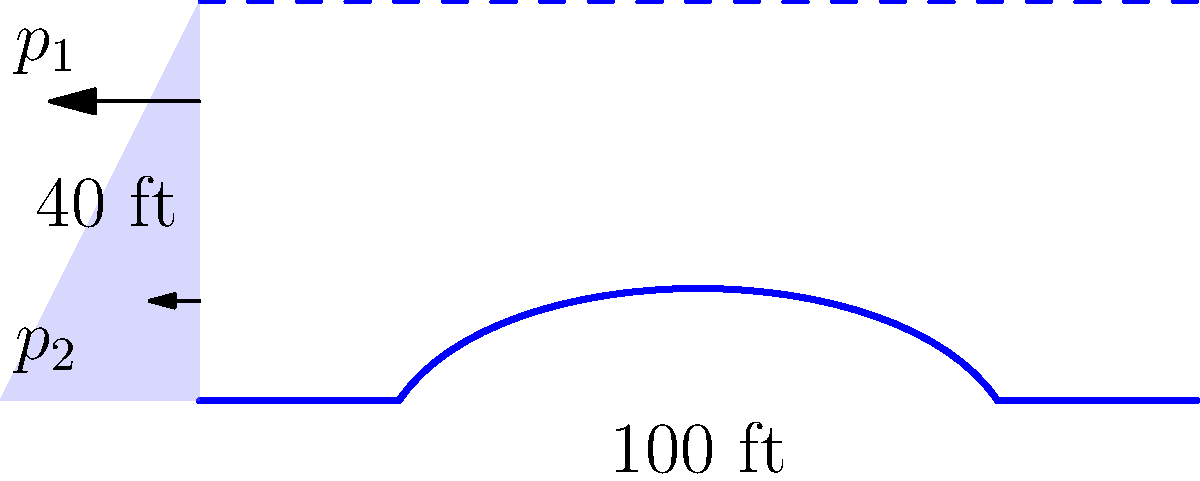A dam wall shaped like Noah's Ark is 100 feet wide and 40 feet high, holding back water to its full height. Calculate the total hydrostatic force on the dam wall, given that water weighs 62.4 lb/ft³. Remember, God's design of the Ark was perfect, so assume the curvature doesn't affect the pressure distribution. Let's approach this step-by-step, keeping in mind that the Lord's wisdom guides our calculations:

1) The hydrostatic pressure increases linearly with depth. At any depth $h$, the pressure is given by:
   $$p = \gamma h$$
   where $\gamma$ is the specific weight of water (62.4 lb/ft³)

2) At the bottom of the dam (h = 40 ft), the maximum pressure is:
   $$p_{max} = 62.4 \times 40 = 2,496 \text{ lb/ft²}$$

3) The pressure distribution is triangular, so the average pressure is half of the maximum:
   $$p_{avg} = \frac{2,496}{2} = 1,248 \text{ lb/ft²}$$

4) The total force is the average pressure multiplied by the area:
   $$F = p_{avg} \times \text{width} \times \text{height}$$
   $$F = 1,248 \times 100 \times 40$$
   $$F = 4,992,000 \text{ lb}$$

5) Convert to tons:
   $$F = \frac{4,992,000}{2000} = 2,496 \text{ tons}$$

Thus, trusting in the Lord's perfect design, we calculate the total hydrostatic force on the ark-shaped dam wall.
Answer: 2,496 tons 